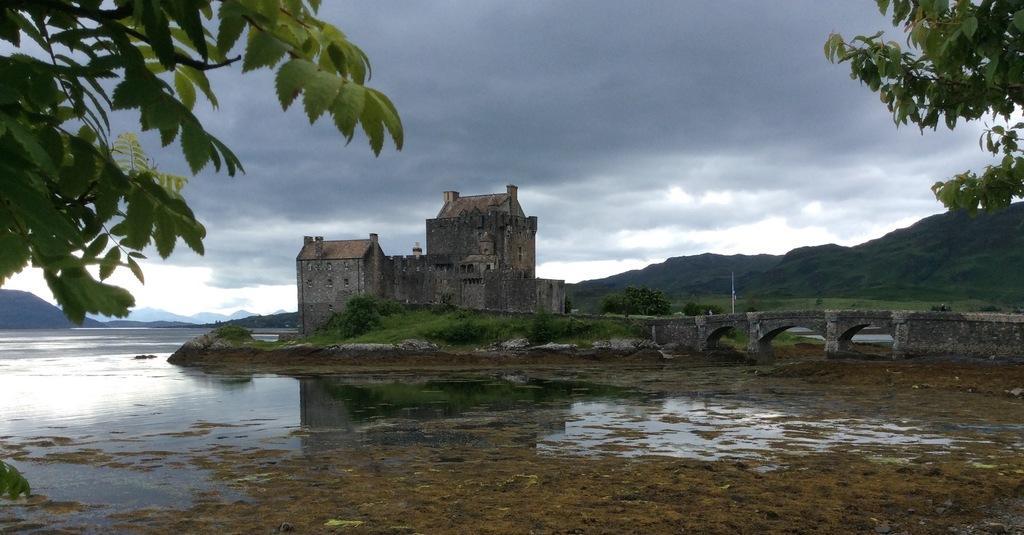Can you describe this image briefly? In the middle of the picture, we see a castle. Beside that, we see trees and grass. On the right side, we see a bridge. At the bottom of the picture, we see soil and water. On either side of the picture, we see trees. There are hills in the background. At the top of the picture, we see the sky. 